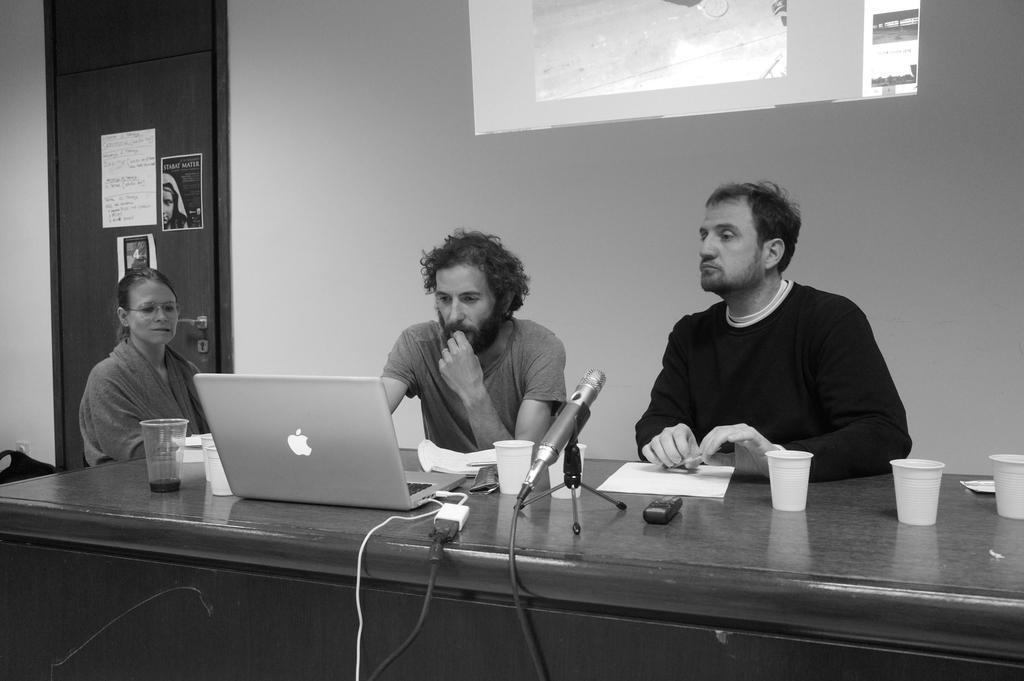Can you describe this image briefly? In the image we can see there are people who are sitting on chair and on table there is laptop, mic with a stand, papers, glass. The image is in black and white colour. 